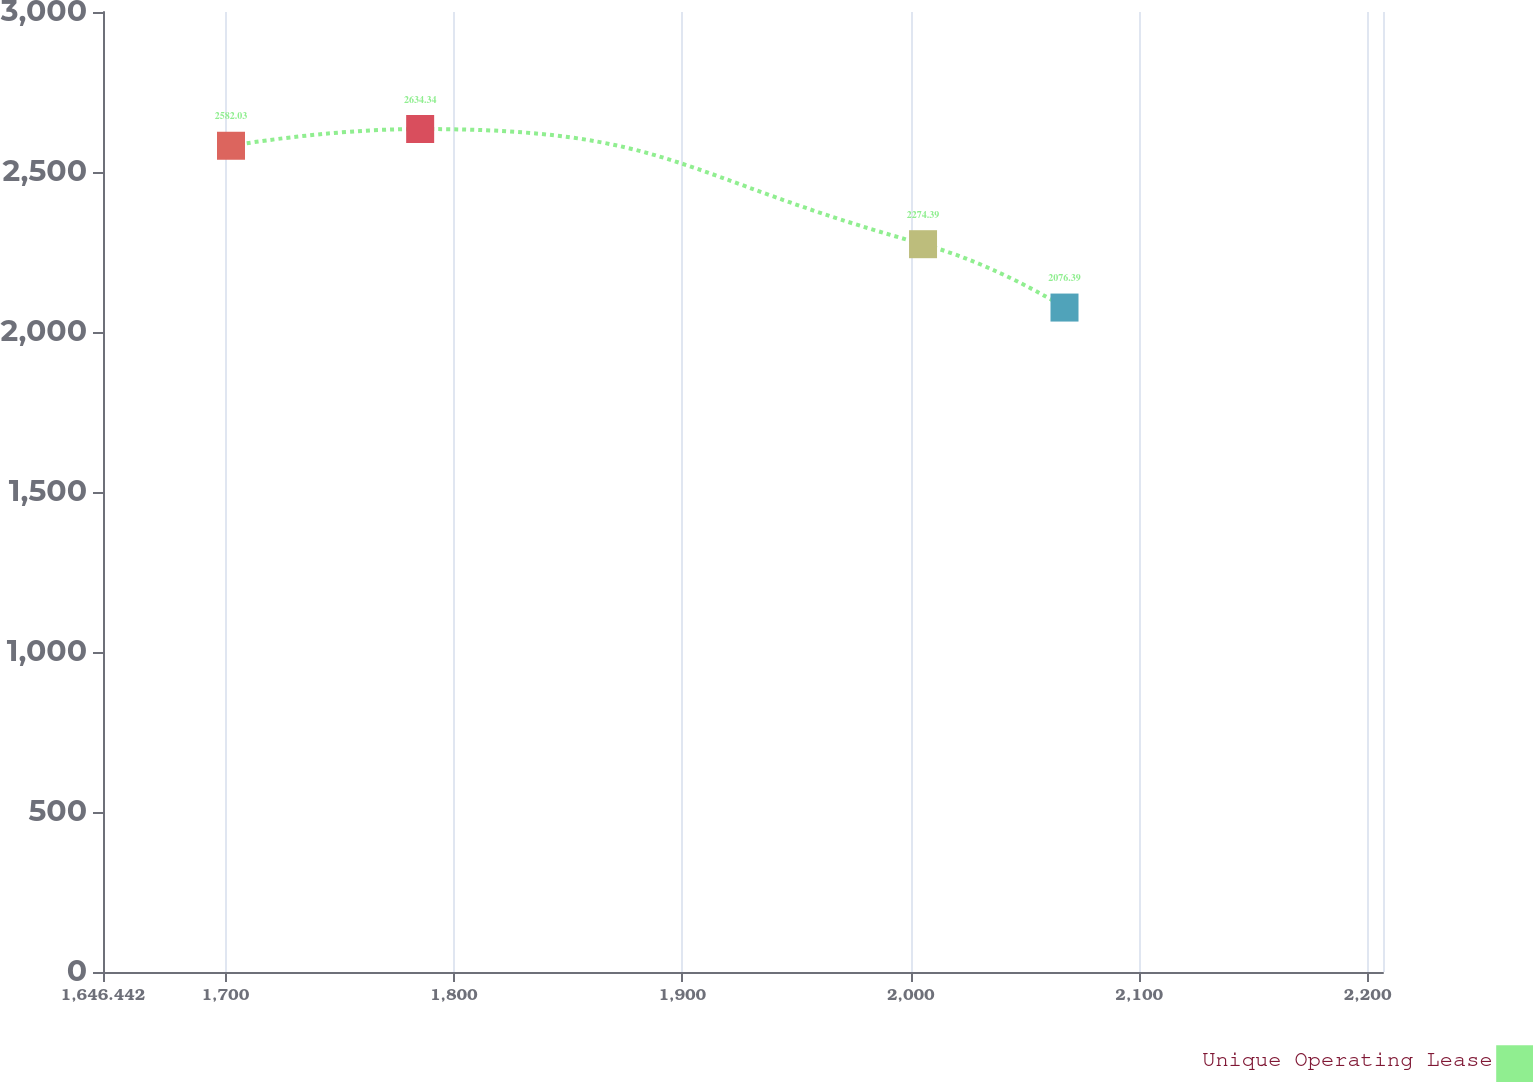Convert chart to OTSL. <chart><loc_0><loc_0><loc_500><loc_500><line_chart><ecel><fcel>Unique Operating Lease<nl><fcel>1702.47<fcel>2582.03<nl><fcel>1785.27<fcel>2634.34<nl><fcel>2005.39<fcel>2274.39<nl><fcel>2067.31<fcel>2076.39<nl><fcel>2262.75<fcel>2469.22<nl></chart> 